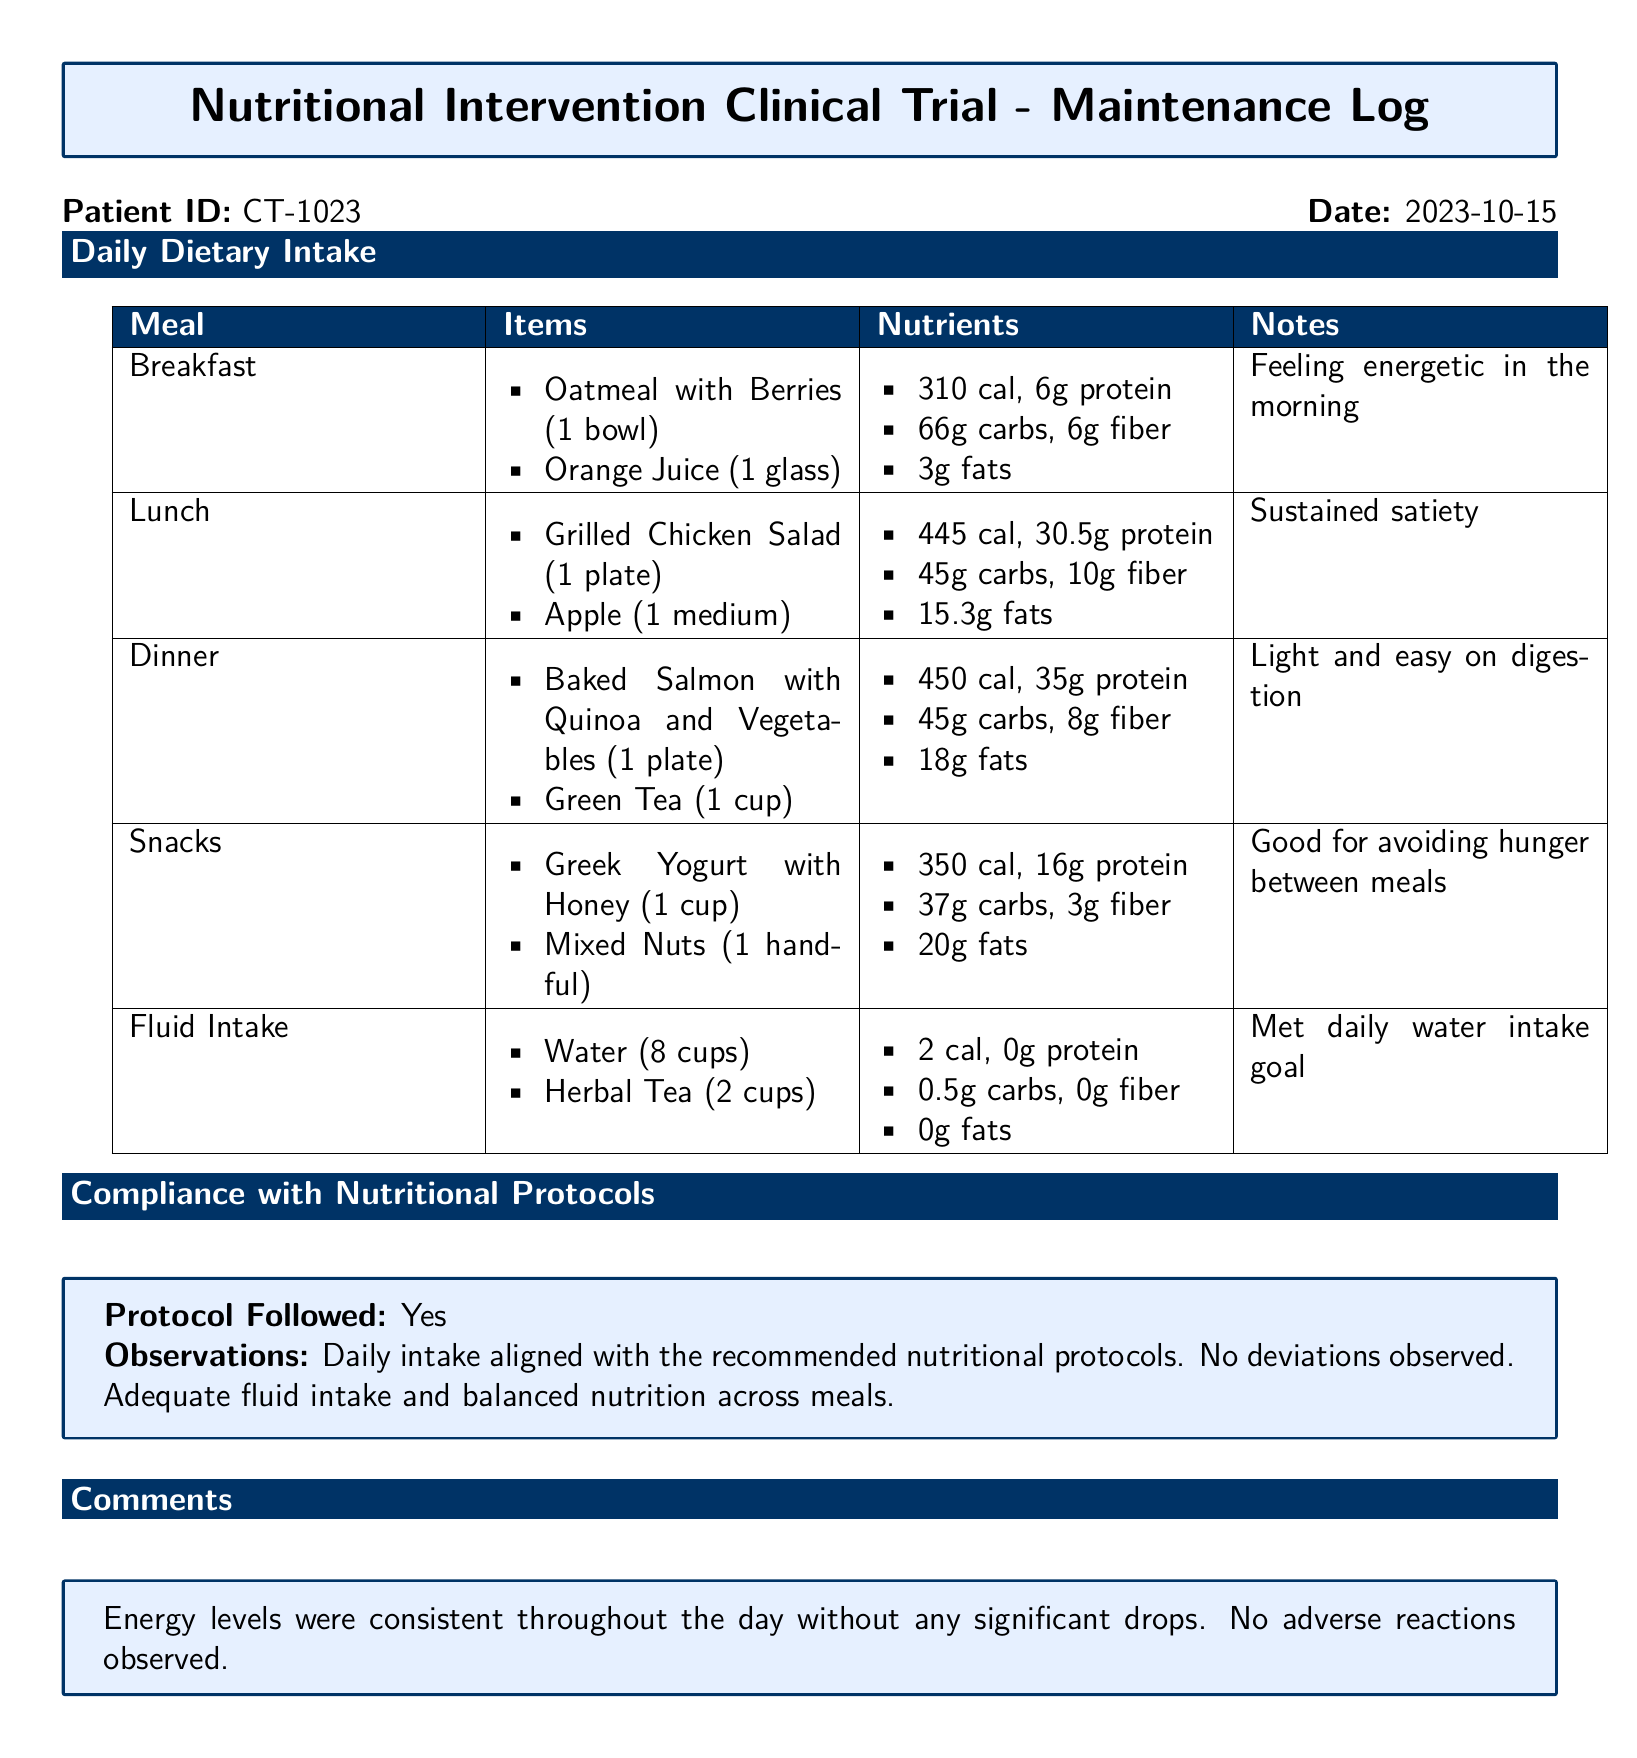what is the patient ID? The patient ID is the unique identifier assigned to the participant in the trial, which is listed prominently in the document.
Answer: CT-1023 what date is recorded in the log? The date is stated at the top of the document as the date of the log entry.
Answer: 2023-10-15 how many calories did the breakfast items provide? The total calories for breakfast are stated in the nutrient section associated with the breakfast meal.
Answer: 310 cal what meal provided the highest protein content? The meal with the highest protein content is identified by comparing protein values across all meals listed.
Answer: Dinner was the nutritional protocol followed? Compliance is explicitly mentioned in the document under the section for compliance with nutritional protocols.
Answer: Yes what do the notes say about lunch? The notes provide insights on the participant's experience related to lunch, reflecting satisfaction and feelings.
Answer: Sustained satiety how many cups of water were consumed? The fluid intake section details the amounts of each beverage consumed, including water.
Answer: 8 cups what was the observation stated in the compliance section? The observations mention the alignment of daily intake with protocols, indicating overall adherence.
Answer: Daily intake aligned with the recommended nutritional protocols did the patient report any adverse reactions? The comments section mentions the patient's experience throughout the day, including any health reactions.
Answer: No 